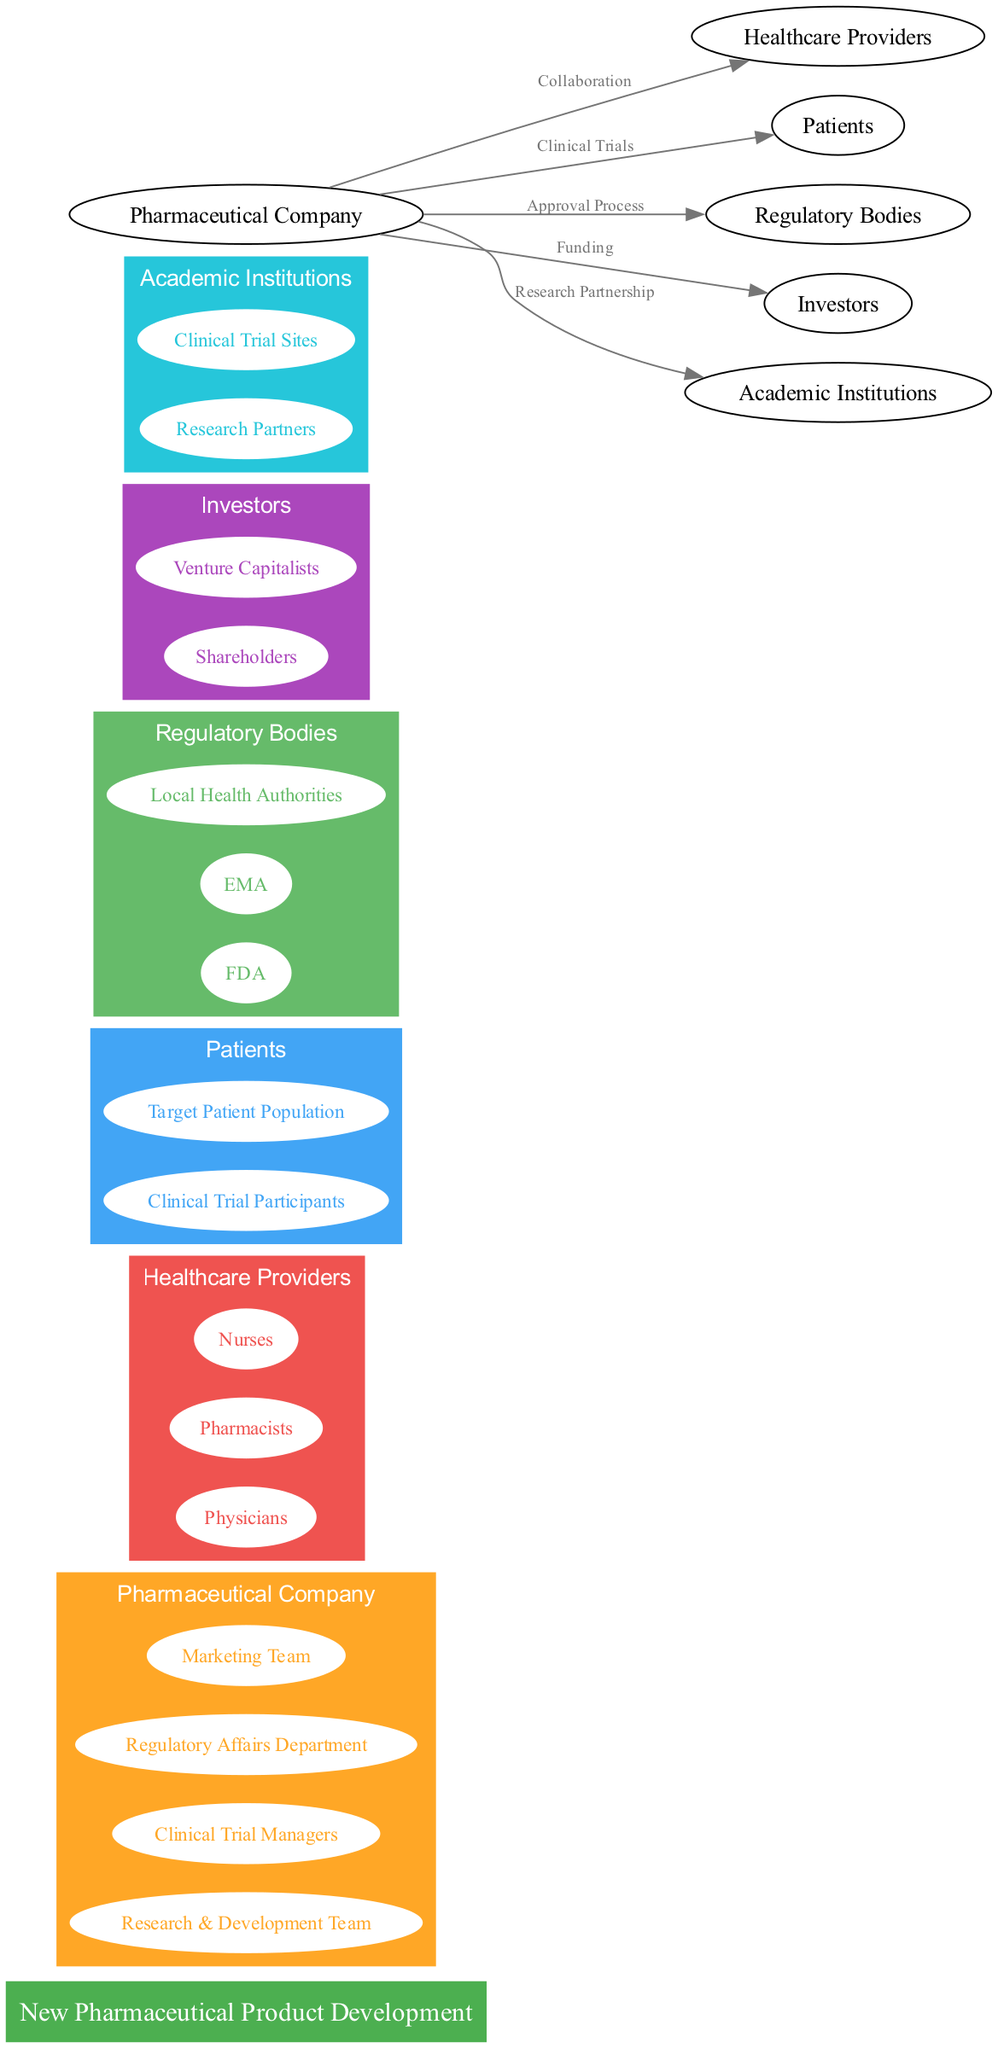What is the central node in the diagram? The central node is explicitly mentioned as "New Pharmaceutical Product Development" at the center of the diagram.
Answer: New Pharmaceutical Product Development How many stakeholder groups are represented in the diagram? By counting all the distinct groups listed under "stakeholderGroups", there are six groups: Pharmaceutical Company, Healthcare Providers, Patients, Regulatory Bodies, Investors, and Academic Institutions.
Answer: 6 What connection exists between the Pharmaceutical Company and Patients? The diagram indicates that the relationship between the Pharmaceutical Company and Patients is labeled as "Clinical Trials". This is a direct connection shown by an edge in the diagram.
Answer: Clinical Trials Which subgroup is part of the Healthcare Providers? Looking under the Healthcare Providers group, it lists "Physicians", "Pharmacists", and "Nurses." Any of these can be the answer, but typically the first mentioned is a common reference.
Answer: Physicians What is the relationship between the Pharmaceutical Company and Academic Institutions? The diagram shows there is a connection labeled "Research Partnership" from the Pharmaceutical Company to Academic Institutions. This indicates a collaborative relationship specifically defined in the diagram.
Answer: Research Partnership Which regulatory body is specifically mentioned in the diagram? The diagram explicitly lists the "FDA" as one of the regulatory bodies in the respective subgroup under Regulatory Bodies.
Answer: FDA How many subgroups are listed under the Investors group? Within the Investors group, there are two subgroups mentioned: "Shareholders" and "Venture Capitalists." Thus, we count them to find the total.
Answer: 2 What is the nature of the connection from the Pharmaceutical Company to Regulatory Bodies? The diagram indicates that this connection is labeled "Approval Process," which describes the relationship as necessary for regulatory-related activities concerning the new pharmaceutical product.
Answer: Approval Process Which group collaborates directly with Healthcare Providers according to the diagram? The diagram indicates that the Pharmaceutical Company has a collaborative connection to Healthcare Providers, as depicted under the connection labeled "Collaboration."
Answer: Pharmaceutical Company 